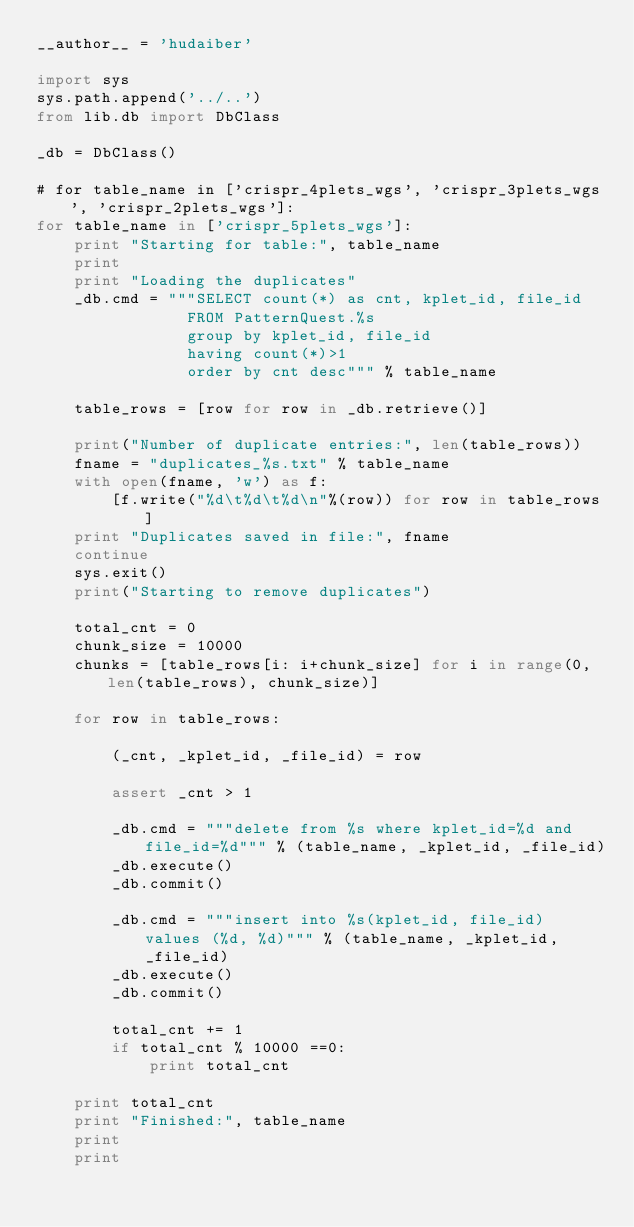Convert code to text. <code><loc_0><loc_0><loc_500><loc_500><_Python_>__author__ = 'hudaiber'

import sys
sys.path.append('../..')
from lib.db import DbClass

_db = DbClass()

# for table_name in ['crispr_4plets_wgs', 'crispr_3plets_wgs', 'crispr_2plets_wgs']:
for table_name in ['crispr_5plets_wgs']:
    print "Starting for table:", table_name
    print
    print "Loading the duplicates"
    _db.cmd = """SELECT count(*) as cnt, kplet_id, file_id
                FROM PatternQuest.%s
                group by kplet_id, file_id
                having count(*)>1
                order by cnt desc""" % table_name

    table_rows = [row for row in _db.retrieve()]

    print("Number of duplicate entries:", len(table_rows))
    fname = "duplicates_%s.txt" % table_name
    with open(fname, 'w') as f:
        [f.write("%d\t%d\t%d\n"%(row)) for row in table_rows]
    print "Duplicates saved in file:", fname
    continue
    sys.exit()
    print("Starting to remove duplicates")

    total_cnt = 0
    chunk_size = 10000
    chunks = [table_rows[i: i+chunk_size] for i in range(0, len(table_rows), chunk_size)]

    for row in table_rows:

        (_cnt, _kplet_id, _file_id) = row

        assert _cnt > 1

        _db.cmd = """delete from %s where kplet_id=%d and file_id=%d""" % (table_name, _kplet_id, _file_id)
        _db.execute()
        _db.commit()

        _db.cmd = """insert into %s(kplet_id, file_id) values (%d, %d)""" % (table_name, _kplet_id, _file_id)
        _db.execute()
        _db.commit()

        total_cnt += 1
        if total_cnt % 10000 ==0:
            print total_cnt

    print total_cnt
    print "Finished:", table_name
    print
    print</code> 